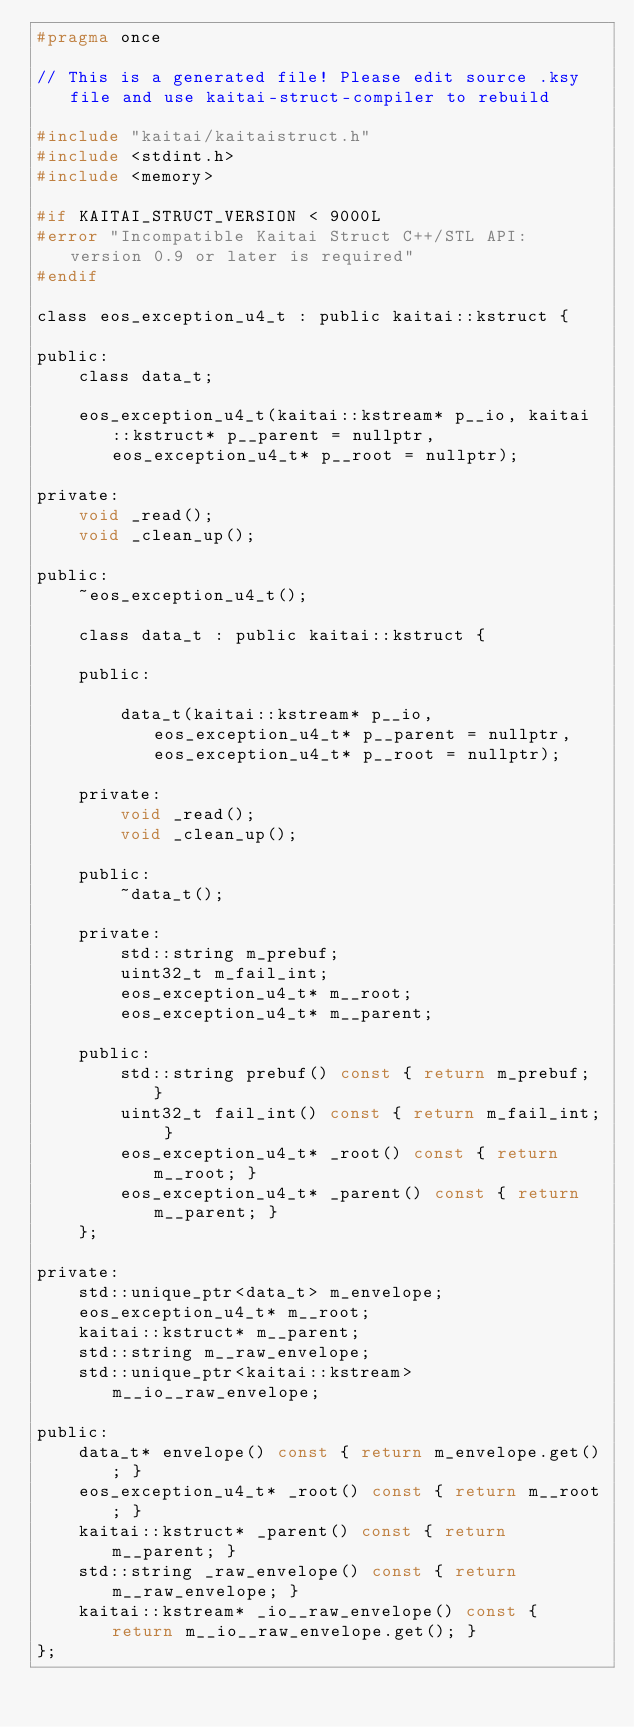<code> <loc_0><loc_0><loc_500><loc_500><_C_>#pragma once

// This is a generated file! Please edit source .ksy file and use kaitai-struct-compiler to rebuild

#include "kaitai/kaitaistruct.h"
#include <stdint.h>
#include <memory>

#if KAITAI_STRUCT_VERSION < 9000L
#error "Incompatible Kaitai Struct C++/STL API: version 0.9 or later is required"
#endif

class eos_exception_u4_t : public kaitai::kstruct {

public:
    class data_t;

    eos_exception_u4_t(kaitai::kstream* p__io, kaitai::kstruct* p__parent = nullptr, eos_exception_u4_t* p__root = nullptr);

private:
    void _read();
    void _clean_up();

public:
    ~eos_exception_u4_t();

    class data_t : public kaitai::kstruct {

    public:

        data_t(kaitai::kstream* p__io, eos_exception_u4_t* p__parent = nullptr, eos_exception_u4_t* p__root = nullptr);

    private:
        void _read();
        void _clean_up();

    public:
        ~data_t();

    private:
        std::string m_prebuf;
        uint32_t m_fail_int;
        eos_exception_u4_t* m__root;
        eos_exception_u4_t* m__parent;

    public:
        std::string prebuf() const { return m_prebuf; }
        uint32_t fail_int() const { return m_fail_int; }
        eos_exception_u4_t* _root() const { return m__root; }
        eos_exception_u4_t* _parent() const { return m__parent; }
    };

private:
    std::unique_ptr<data_t> m_envelope;
    eos_exception_u4_t* m__root;
    kaitai::kstruct* m__parent;
    std::string m__raw_envelope;
    std::unique_ptr<kaitai::kstream> m__io__raw_envelope;

public:
    data_t* envelope() const { return m_envelope.get(); }
    eos_exception_u4_t* _root() const { return m__root; }
    kaitai::kstruct* _parent() const { return m__parent; }
    std::string _raw_envelope() const { return m__raw_envelope; }
    kaitai::kstream* _io__raw_envelope() const { return m__io__raw_envelope.get(); }
};
</code> 